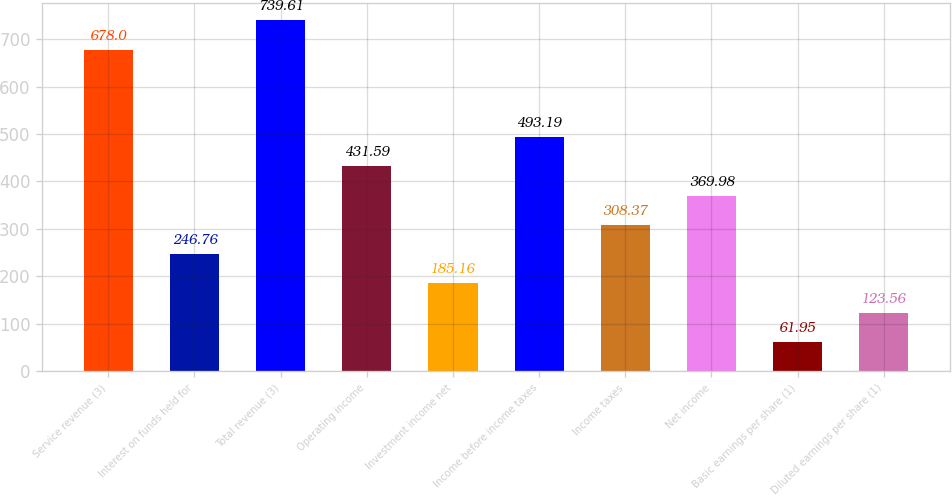Convert chart to OTSL. <chart><loc_0><loc_0><loc_500><loc_500><bar_chart><fcel>Service revenue (3)<fcel>Interest on funds held for<fcel>Total revenue (3)<fcel>Operating income<fcel>Investment income net<fcel>Income before income taxes<fcel>Income taxes<fcel>Net income<fcel>Basic earnings per share (1)<fcel>Diluted earnings per share (1)<nl><fcel>678<fcel>246.76<fcel>739.61<fcel>431.59<fcel>185.16<fcel>493.19<fcel>308.37<fcel>369.98<fcel>61.95<fcel>123.56<nl></chart> 